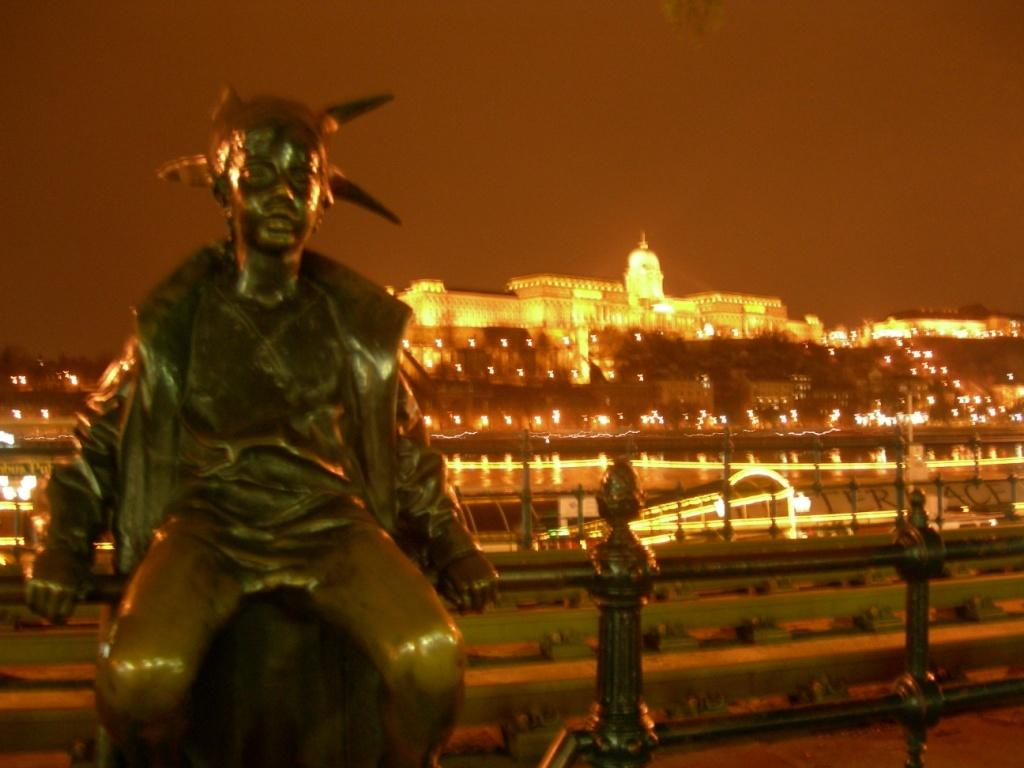What is the main subject in the image? There is a statue in the image. How is the statue positioned in the image? The statue is on an iron grill. What can be seen in the background of the image? There are buildings in the background of the image. What is the condition of the lighting on the buildings? The buildings have lighting. How many times has the statue said good-bye in the image? The statue does not speak or express emotions in the image, so it cannot say good-bye. Can you tell me how many copies of the statue are present in the image? There is only one statue visible in the image, so there are no copies. 